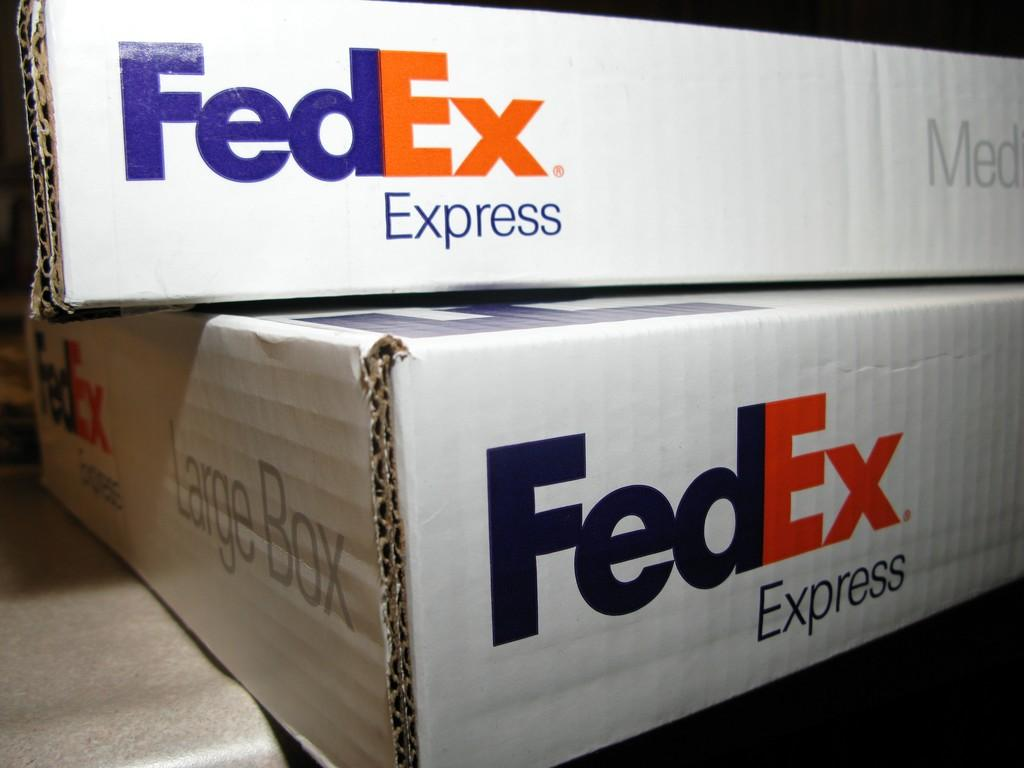<image>
Present a compact description of the photo's key features. A FedEx Express box is not top of another FedEx box. 